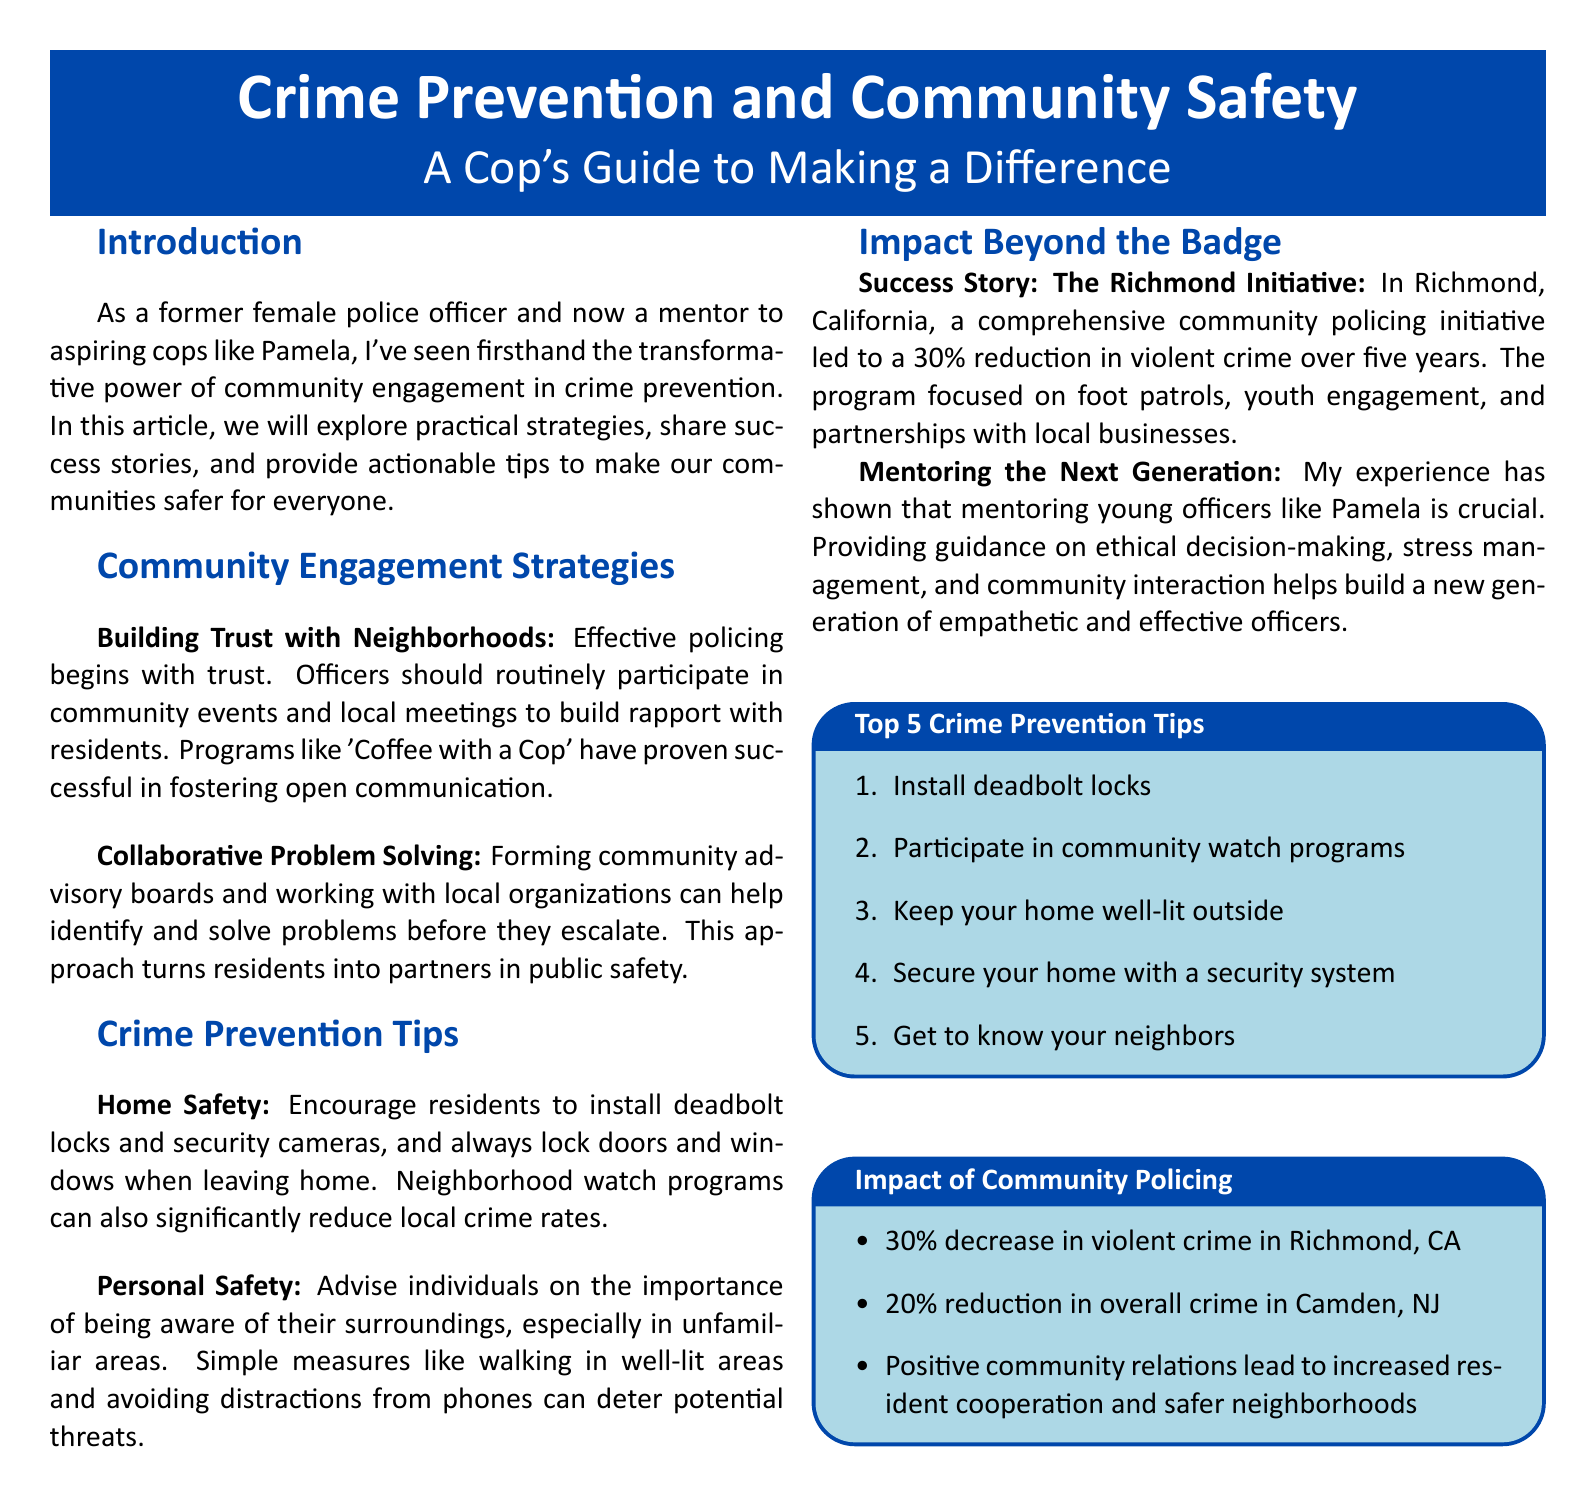What is the article about? The article focuses on community engagement strategies, crime prevention tips, and the impact of policing beyond the badge.
Answer: Crime Prevention and Community Safety Who is the author of the article? The author is a former female police officer and mentor.
Answer: A former female police officer What program is mentioned for building rapport with residents? This program encourages open communication between officers and the community.
Answer: Coffee with a Cop By what percentage did violent crime decrease in Richmond, CA? This figure illustrates the success of the community policing initiative in Richmond.
Answer: 30 percent What is one of the personal safety tips provided in the article? This advice helps individuals to stay safe in unfamiliar surroundings.
Answer: Be aware of surroundings What are residents encouraged to install for home safety? This enhancement increases security in residential properties.
Answer: Deadbolt locks What is the impact of community policing in Camden, NJ? This statistic reflects the effectiveness of community-oriented policing strategies in that area.
Answer: 20 percent reduction What program can reduce local crime rates according to the article? This community initiative involves neighborhood collaboration for safety.
Answer: Neighborhood watch programs 